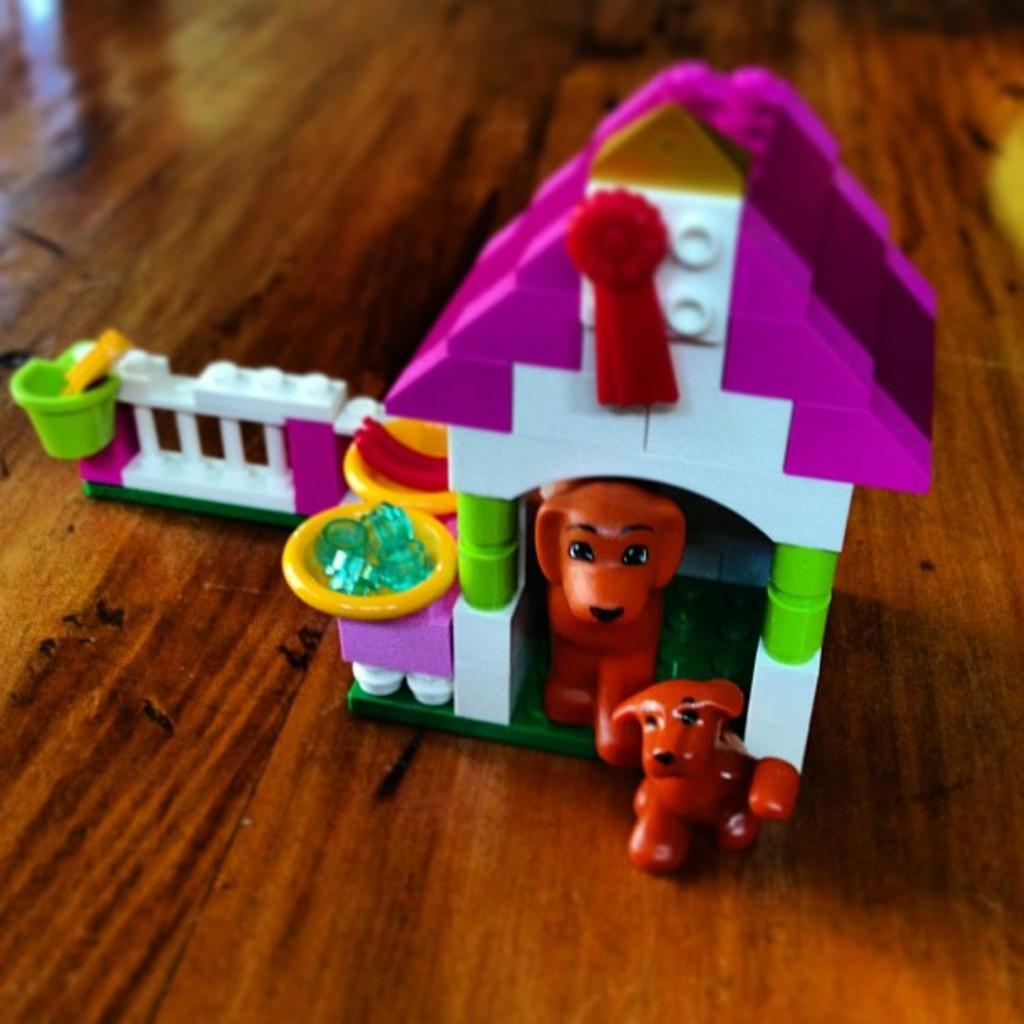What type of toy is present in the image? There is a toy puppy house in the image. Where is the toy puppy house located? The toy puppy house is kept on a wooden surface. What type of degree can be seen hanging on the wall near the toy puppy house? There is no degree present in the image; it only features a toy puppy house on a wooden surface. 